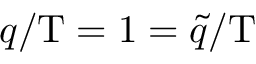Convert formula to latex. <formula><loc_0><loc_0><loc_500><loc_500>q / T = 1 = \tilde { q } / T</formula> 